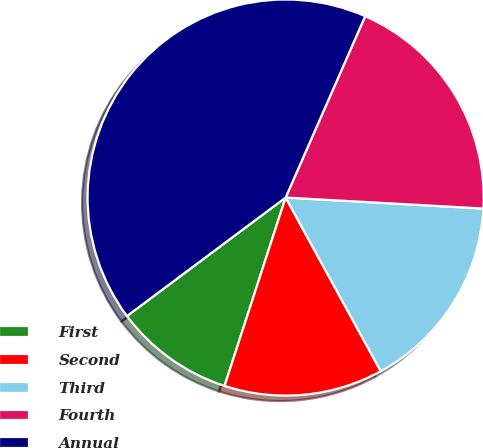<chart> <loc_0><loc_0><loc_500><loc_500><pie_chart><fcel>First<fcel>Second<fcel>Third<fcel>Fourth<fcel>Annual<nl><fcel>9.8%<fcel>12.97%<fcel>16.14%<fcel>19.31%<fcel>41.79%<nl></chart> 